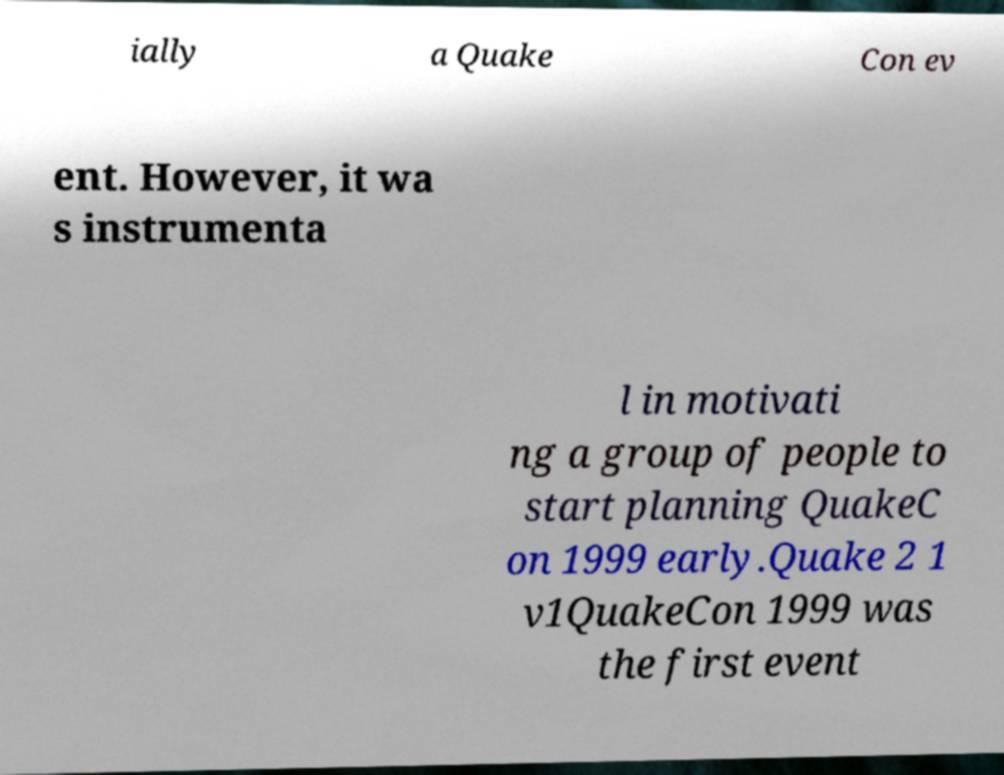Please read and relay the text visible in this image. What does it say? ially a Quake Con ev ent. However, it wa s instrumenta l in motivati ng a group of people to start planning QuakeC on 1999 early.Quake 2 1 v1QuakeCon 1999 was the first event 